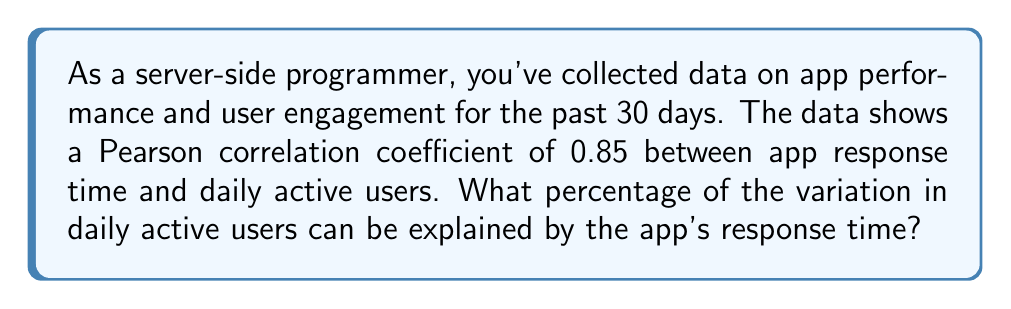Could you help me with this problem? To solve this problem, we need to understand the relationship between the Pearson correlation coefficient (r) and the coefficient of determination (R²). The coefficient of determination represents the proportion of variance in the dependent variable that is predictable from the independent variable.

Step 1: Recall that R² is equal to the square of the Pearson correlation coefficient (r).
$$R^2 = r^2$$

Step 2: We are given that r = 0.85. Let's substitute this into our equation:
$$R^2 = (0.85)^2$$

Step 3: Calculate R²:
$$R^2 = 0.7225$$

Step 4: Convert to a percentage by multiplying by 100:
$$0.7225 \times 100 = 72.25\%$$

Therefore, 72.25% of the variation in daily active users can be explained by the app's response time.
Answer: 72.25% 